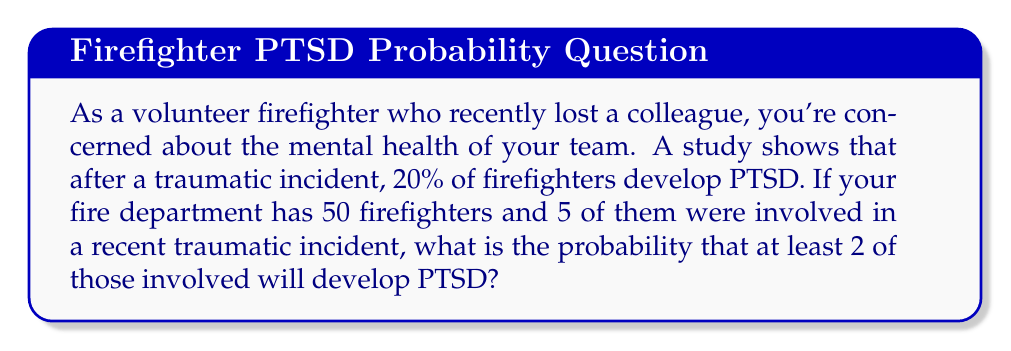Solve this math problem. Let's approach this step-by-step using the binomial probability distribution:

1) We have $n = 5$ firefighters involved in the incident.
2) The probability of developing PTSD is $p = 0.20$ (20%).
3) We want to find the probability of at least 2 firefighters developing PTSD.

We can calculate this by finding the probability of 2, 3, 4, or 5 firefighters developing PTSD and summing these probabilities.

The probability of exactly $k$ successes in $n$ trials is given by the binomial probability formula:

$$ P(X = k) = \binom{n}{k} p^k (1-p)^{n-k} $$

Where $\binom{n}{k}$ is the binomial coefficient, calculated as:

$$ \binom{n}{k} = \frac{n!}{k!(n-k)!} $$

Let's calculate for each case:

For $k = 2$:
$$ P(X = 2) = \binom{5}{2} (0.20)^2 (0.80)^3 = 10 \cdot 0.04 \cdot 0.512 = 0.2048 $$

For $k = 3$:
$$ P(X = 3) = \binom{5}{3} (0.20)^3 (0.80)^2 = 10 \cdot 0.008 \cdot 0.64 = 0.0512 $$

For $k = 4$:
$$ P(X = 4) = \binom{5}{4} (0.20)^4 (0.80)^1 = 5 \cdot 0.0016 \cdot 0.80 = 0.0064 $$

For $k = 5$:
$$ P(X = 5) = \binom{5}{5} (0.20)^5 (0.80)^0 = 1 \cdot 0.00032 \cdot 1 = 0.00032 $$

The probability of at least 2 firefighters developing PTSD is the sum of these probabilities:

$$ P(X \geq 2) = 0.2048 + 0.0512 + 0.0064 + 0.00032 = 0.26272 $$
Answer: The probability that at least 2 of the 5 firefighters involved in the traumatic incident will develop PTSD is approximately 0.2627 or 26.27%. 